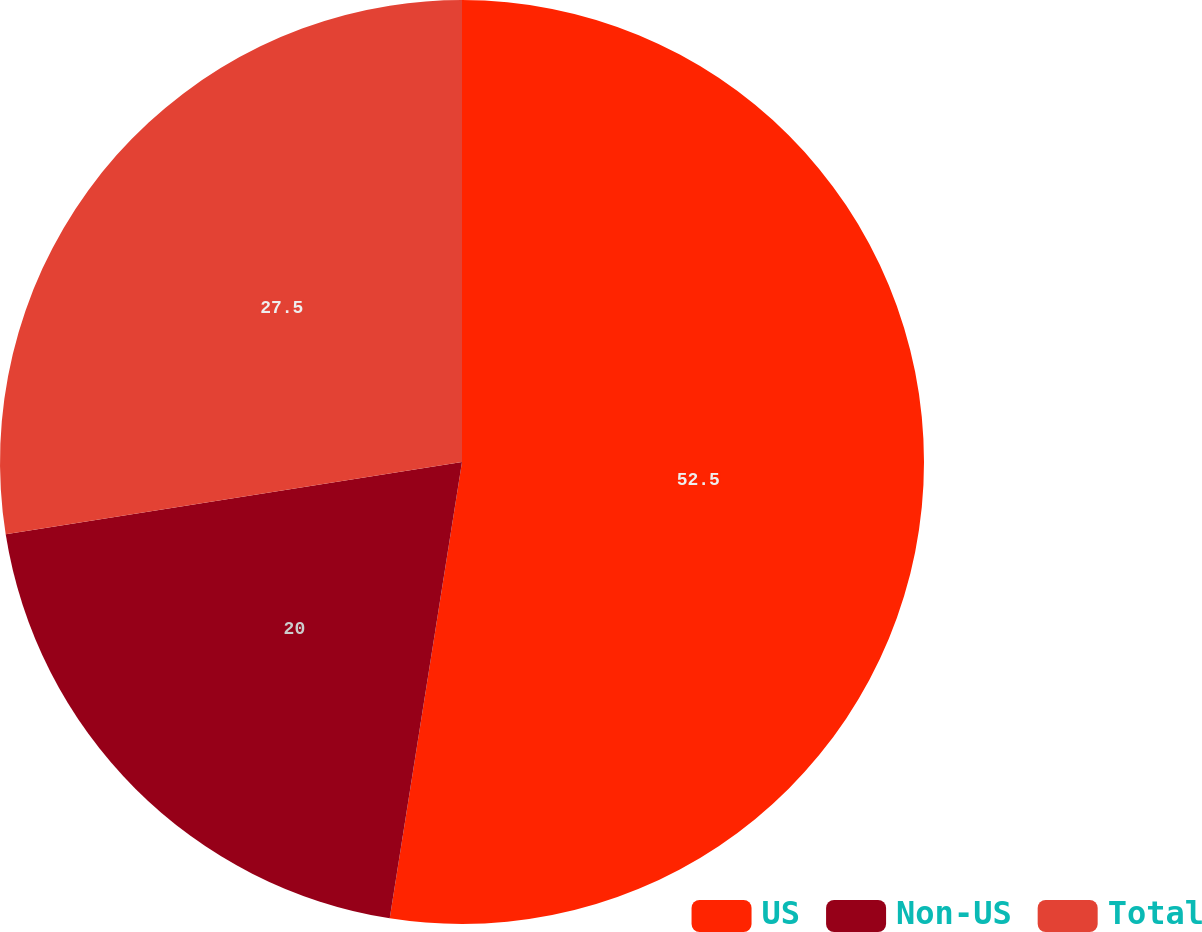Convert chart. <chart><loc_0><loc_0><loc_500><loc_500><pie_chart><fcel>US<fcel>Non-US<fcel>Total<nl><fcel>52.5%<fcel>20.0%<fcel>27.5%<nl></chart> 